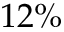Convert formula to latex. <formula><loc_0><loc_0><loc_500><loc_500>1 2 \%</formula> 